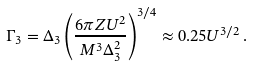<formula> <loc_0><loc_0><loc_500><loc_500>\Gamma _ { 3 } = \Delta _ { 3 } \left ( \frac { 6 \pi Z U ^ { 2 } } { M ^ { 3 } \Delta _ { 3 } ^ { 2 } } \right ) ^ { 3 / 4 } \approx 0 . 2 5 U ^ { 3 / 2 } \, .</formula> 